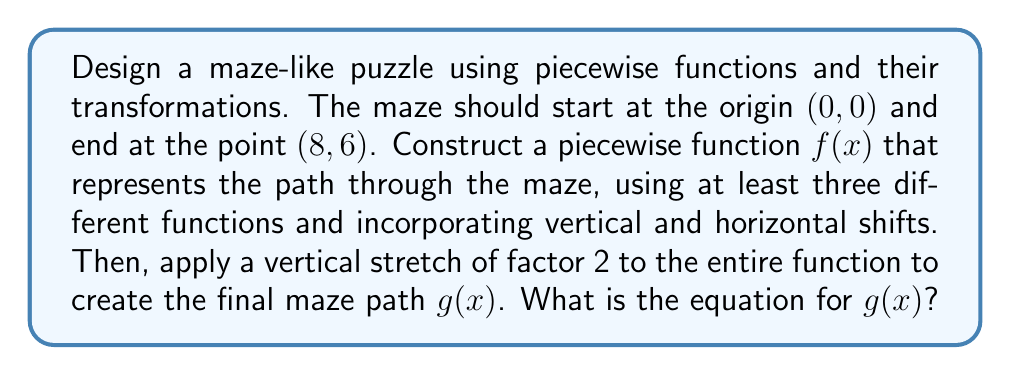Give your solution to this math problem. Let's approach this step-by-step:

1) First, we need to create a piecewise function $f(x)$ that starts at (0,0) and ends at (8,6). We'll use three different functions:

   For $0 \leq x < 2$: $f_1(x) = x^2$
   For $2 \leq x < 5$: $f_2(x) = -\frac{1}{2}(x-4)^2 + 4$
   For $5 \leq x \leq 8$: $f_3(x) = \frac{1}{3}(x-5) + 3$

2) Let's verify that these functions connect smoothly:
   - At $x=2$: $f_1(2) = 2^2 = 4$ and $f_2(2) = -\frac{1}{2}(2-4)^2 + 4 = 4$
   - At $x=5$: $f_2(5) = -\frac{1}{2}(5-4)^2 + 4 = 3$ and $f_3(5) = \frac{1}{3}(5-5) + 3 = 3$

3) We can now write our piecewise function $f(x)$:

   $$f(x) = \begin{cases} 
   x^2 & \text{if } 0 \leq x < 2 \\
   -\frac{1}{2}(x-4)^2 + 4 & \text{if } 2 \leq x < 5 \\
   \frac{1}{3}(x-5) + 3 & \text{if } 5 \leq x \leq 8
   \end{cases}$$

4) Now, we need to apply a vertical stretch of factor 2 to create $g(x)$. This means multiplying the entire function by 2:

   $$g(x) = 2f(x) = \begin{cases} 
   2x^2 & \text{if } 0 \leq x < 2 \\
   -1(x-4)^2 + 8 & \text{if } 2 \leq x < 5 \\
   \frac{2}{3}(x-5) + 6 & \text{if } 5 \leq x \leq 8
   \end{cases}$$

5) Let's verify that $g(x)$ still starts at (0,0) and ends at (8,6):
   - At $x=0$: $g(0) = 2(0^2) = 0$
   - At $x=8$: $g(8) = \frac{2}{3}(8-5) + 6 = 2 + 6 = 8$

Thus, we have successfully created our maze-like puzzle function $g(x)$.
Answer: $$g(x) = \begin{cases} 
2x^2 & \text{if } 0 \leq x < 2 \\
-1(x-4)^2 + 8 & \text{if } 2 \leq x < 5 \\
\frac{2}{3}(x-5) + 6 & \text{if } 5 \leq x \leq 8
\end{cases}$$ 